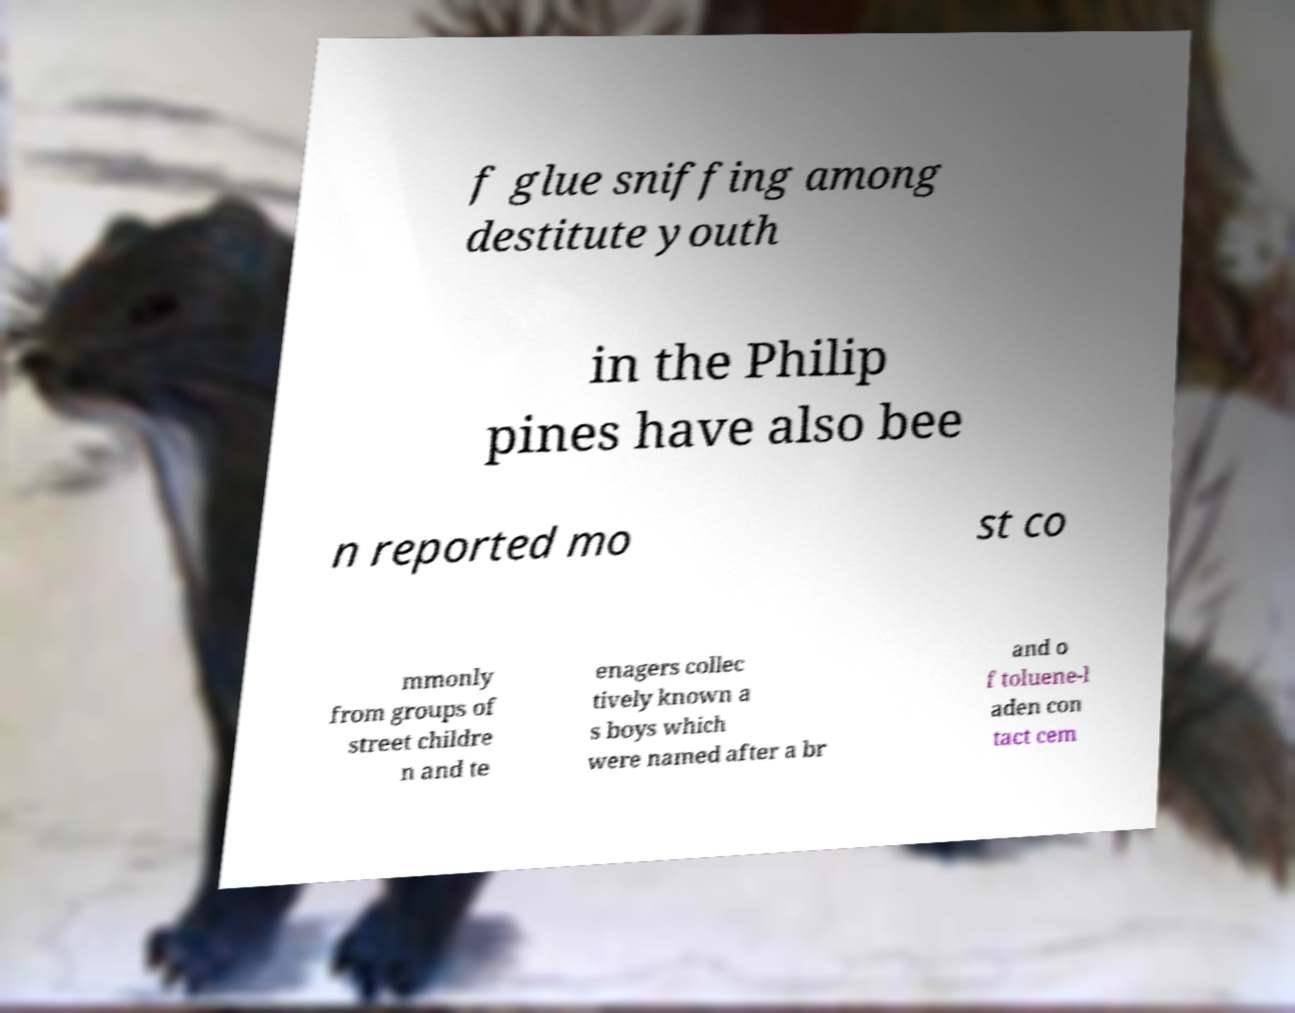Could you assist in decoding the text presented in this image and type it out clearly? f glue sniffing among destitute youth in the Philip pines have also bee n reported mo st co mmonly from groups of street childre n and te enagers collec tively known a s boys which were named after a br and o f toluene-l aden con tact cem 